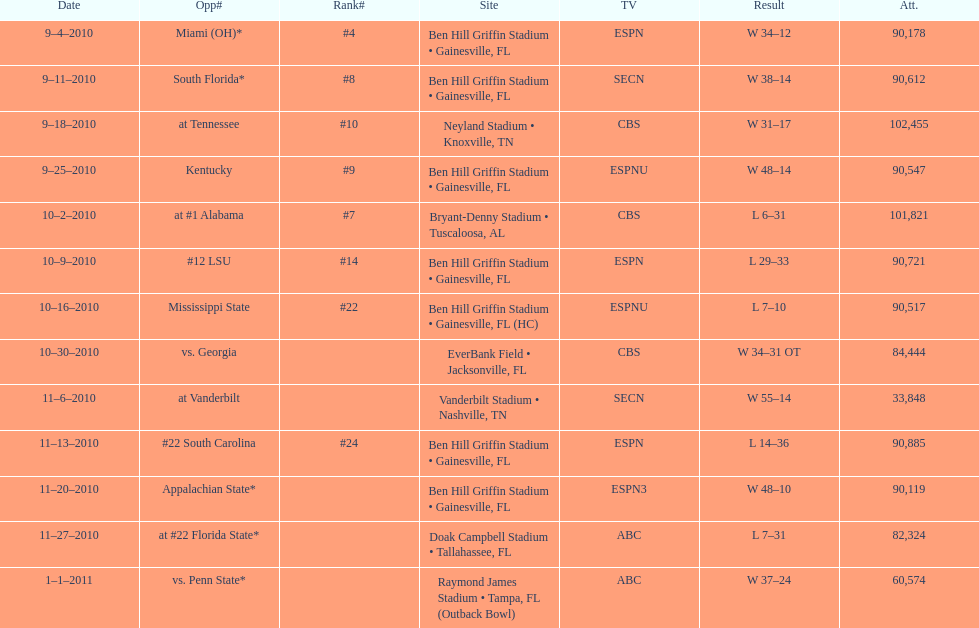What was the most the university of florida won by? 41 points. 